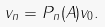Convert formula to latex. <formula><loc_0><loc_0><loc_500><loc_500>v _ { n } = P _ { n } ( A ) v _ { 0 } .</formula> 